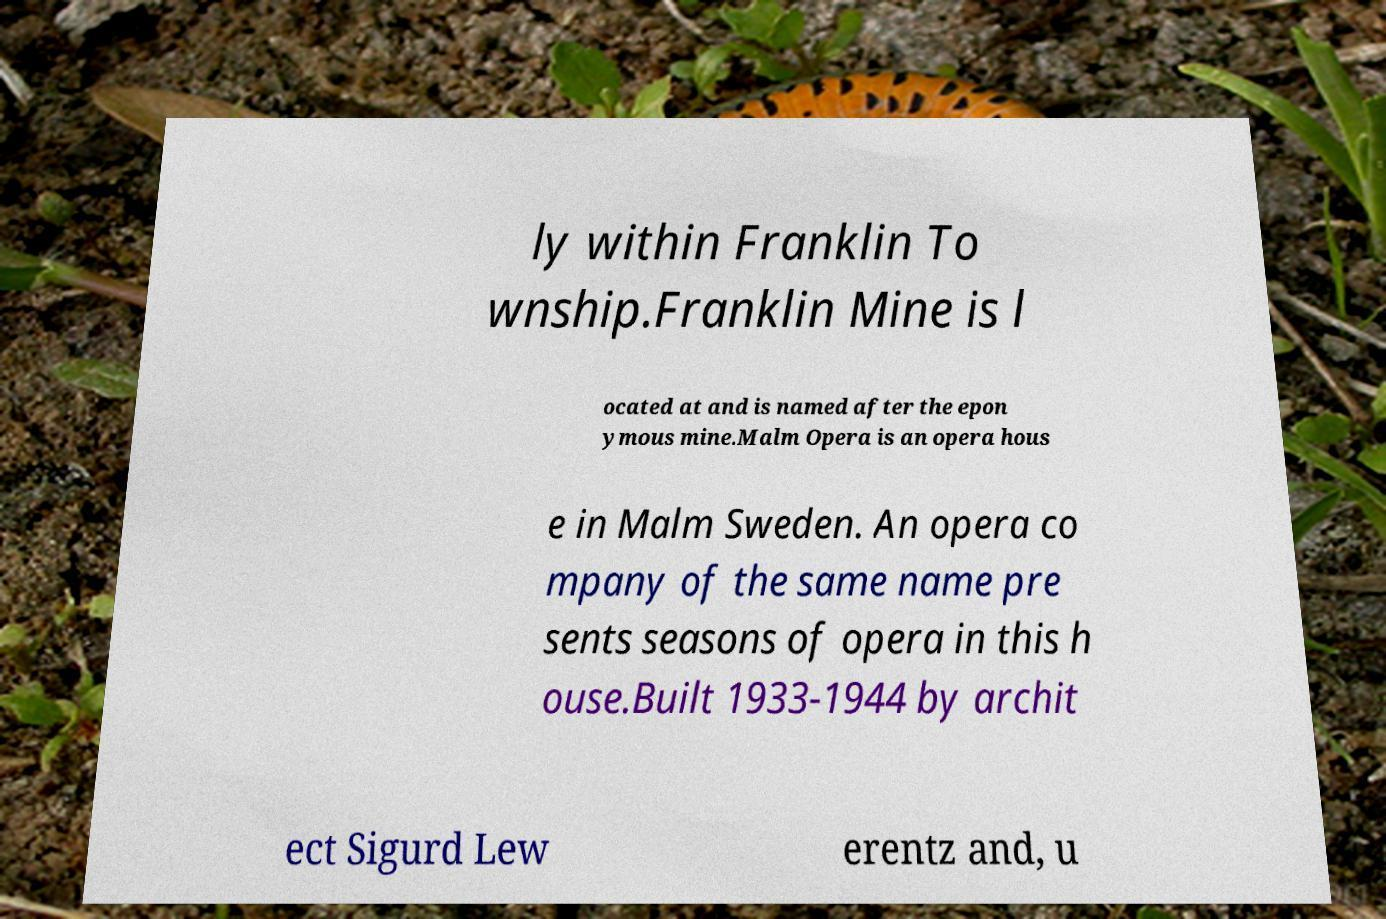Please identify and transcribe the text found in this image. ly within Franklin To wnship.Franklin Mine is l ocated at and is named after the epon ymous mine.Malm Opera is an opera hous e in Malm Sweden. An opera co mpany of the same name pre sents seasons of opera in this h ouse.Built 1933-1944 by archit ect Sigurd Lew erentz and, u 